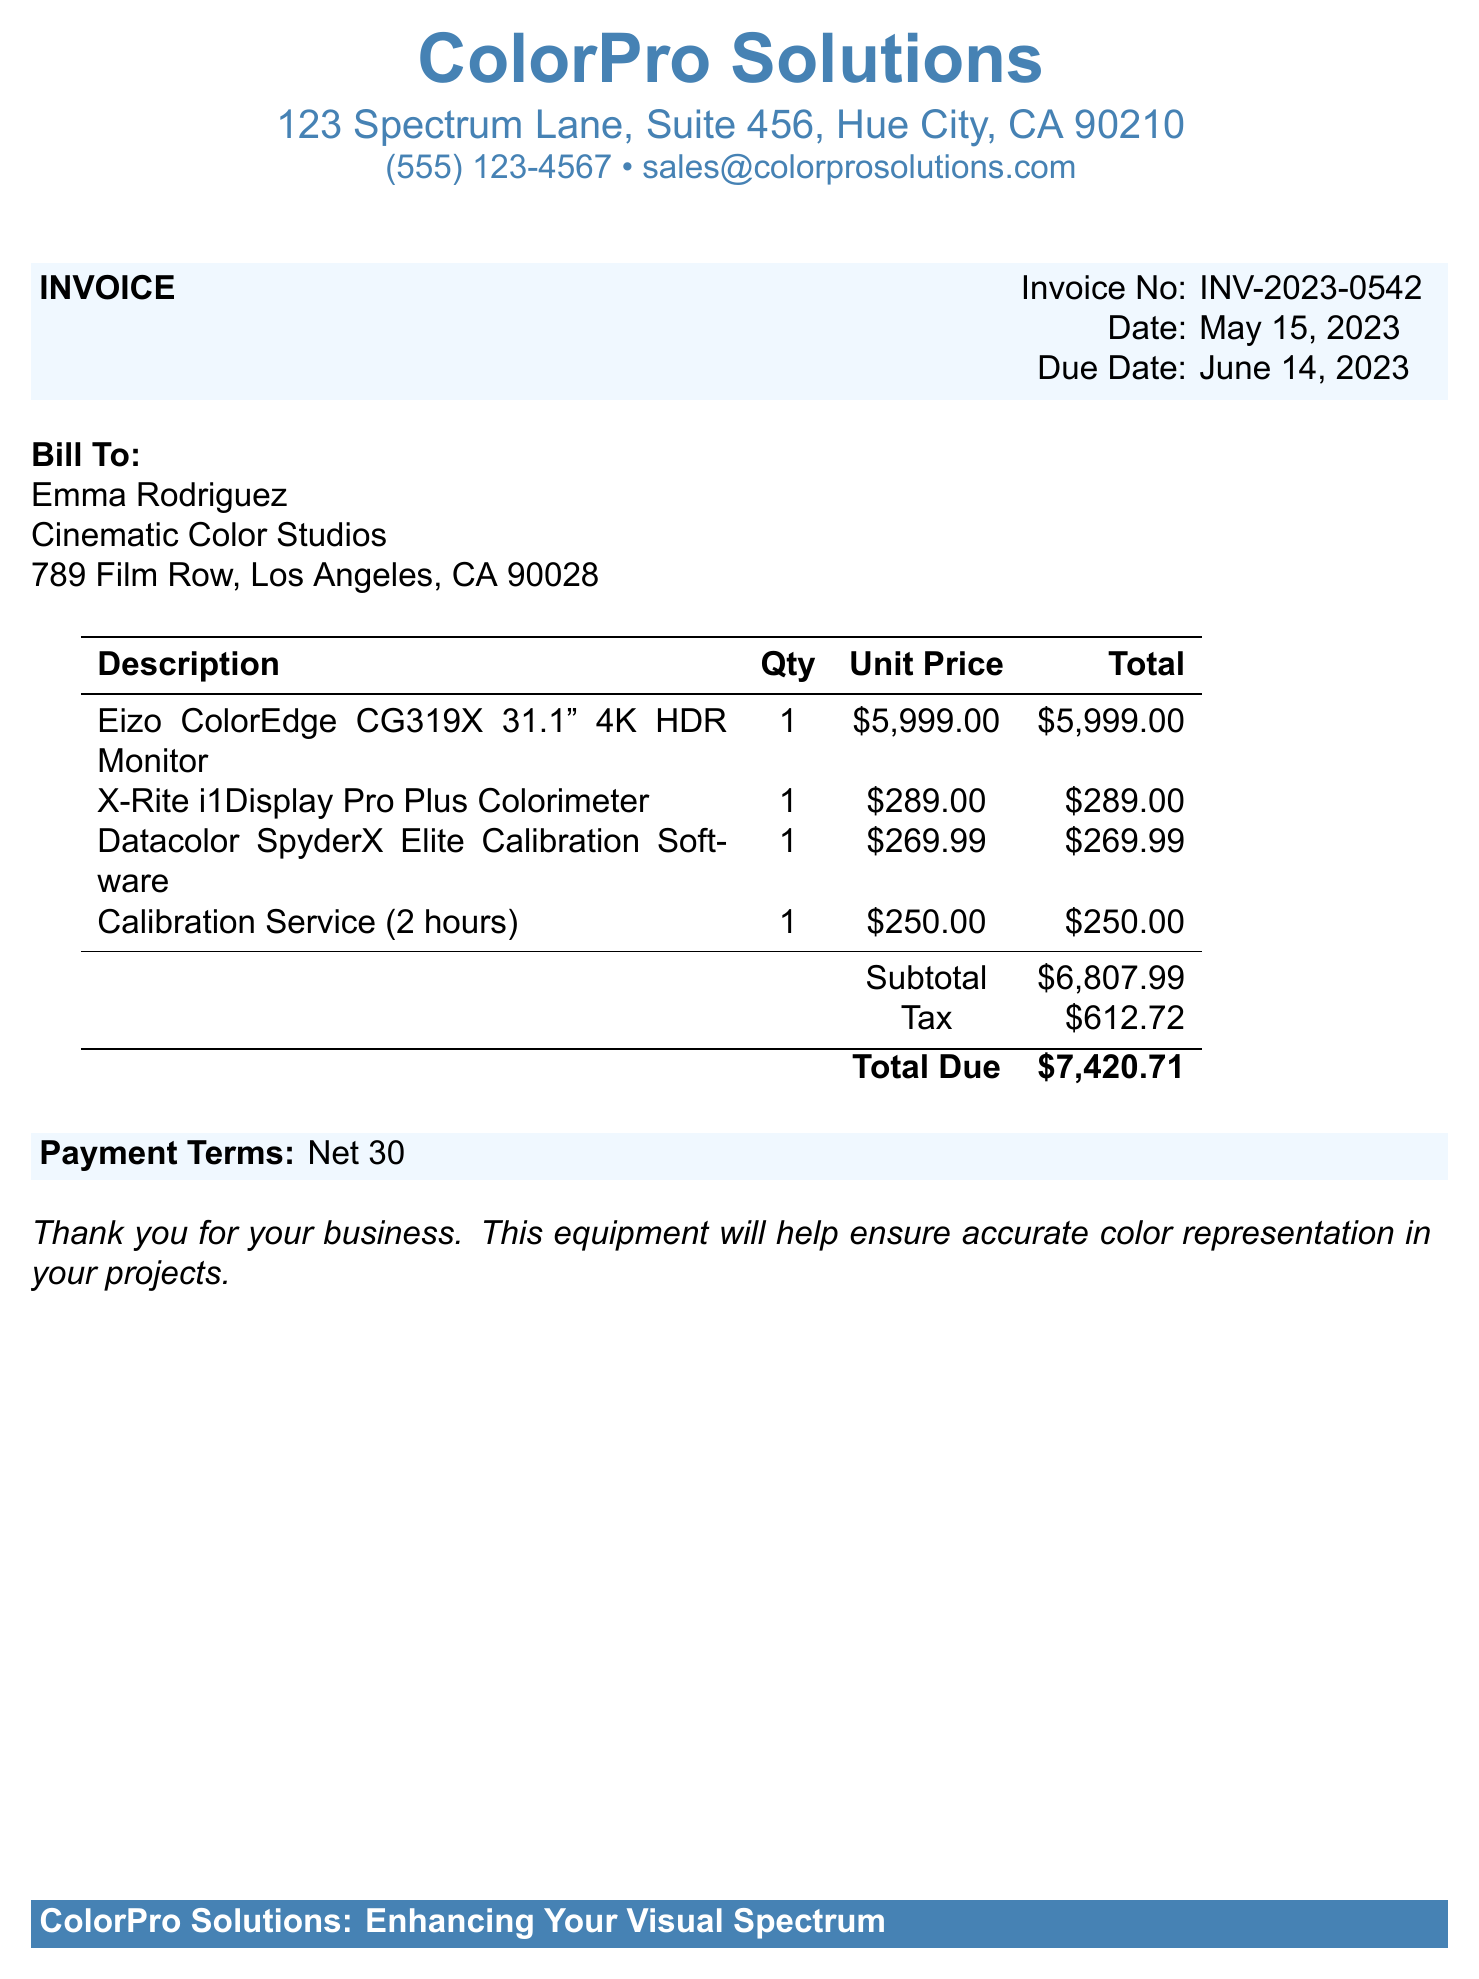What is the invoice number? The invoice number is listed in the document under 'Invoice No'.
Answer: INV-2023-0542 Who is the bill to? The 'Bill To' section contains the name of the individual or company.
Answer: Emma Rodriguez What is the total due? Total due is calculated from the subtotal and tax provided in the invoice.
Answer: $7,420.71 How many colorimeters are listed in the invoice? The quantity of colorimeters can be found in the description table.
Answer: 1 What is the date of the invoice? The date is provided in the invoice details section.
Answer: May 15, 2023 What is the unit price of the Eizo monitor? The unit price is detailed in the itemized list within the document.
Answer: $5,999.00 What service is offered for $250? The description of services includes a specific calibration service charge.
Answer: Calibration Service (2 hours) What is the tax amount listed in the document? Tax amount is stated in an itemized format in the invoice section.
Answer: $612.72 